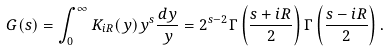<formula> <loc_0><loc_0><loc_500><loc_500>G ( s ) = \int _ { 0 } ^ { \infty } K _ { i R } ( y ) y ^ { s } \frac { d y } { y } = 2 ^ { s - 2 } \Gamma \left ( \frac { s + i R } 2 \right ) \Gamma \left ( \frac { s - i R } 2 \right ) .</formula> 